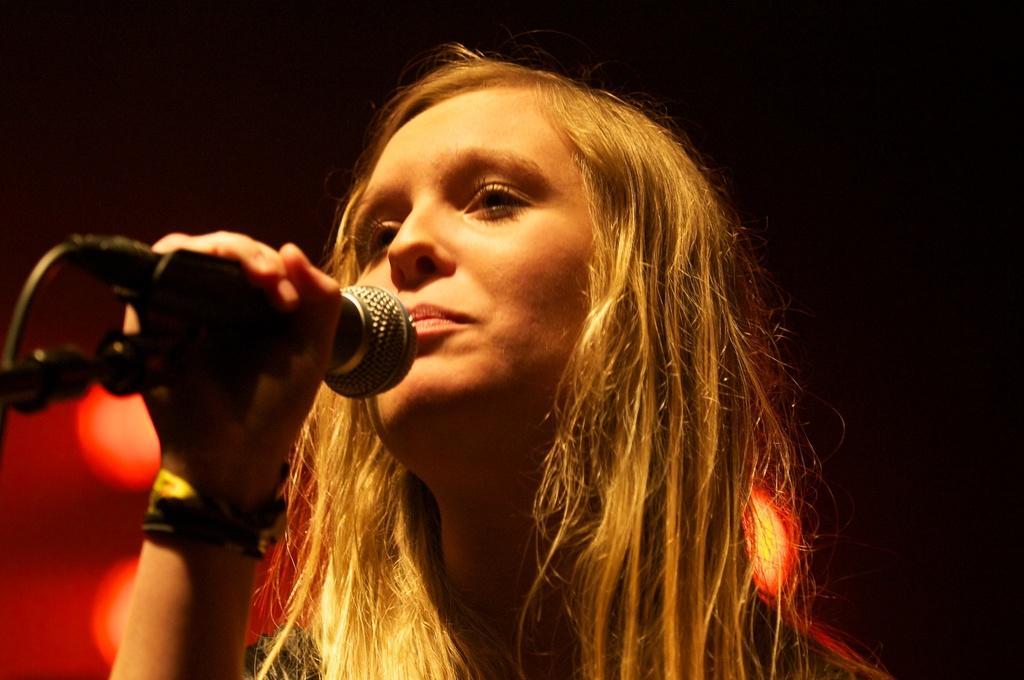Please provide a concise description of this image. This image consists of a woman standing and holding a mike in her hand, who is half visible. The background is dark in color. In the left bottom, lights are visible. This image is taken on the stage during night time. 